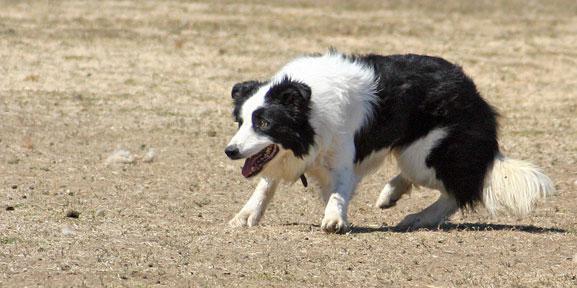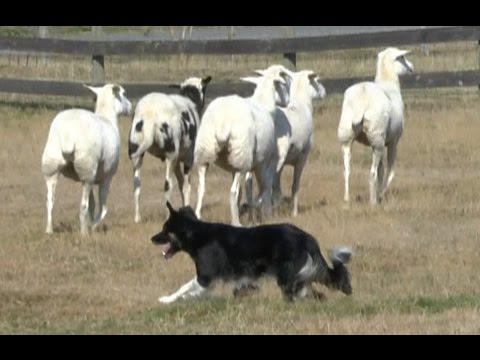The first image is the image on the left, the second image is the image on the right. Assess this claim about the two images: "There are less than three animals in one of the images.". Correct or not? Answer yes or no. Yes. The first image is the image on the left, the second image is the image on the right. For the images shown, is this caption "The right image contains exactly three sheep." true? Answer yes or no. No. 